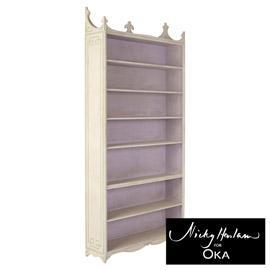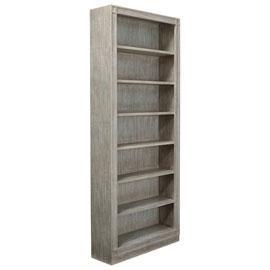The first image is the image on the left, the second image is the image on the right. Given the left and right images, does the statement "One brown bookcase has a grid of same-size square compartments, and the other brown bookcase has closed-front storage at the bottom." hold true? Answer yes or no. No. The first image is the image on the left, the second image is the image on the right. Examine the images to the left and right. Is the description "There are exactly two empty bookcases." accurate? Answer yes or no. Yes. 